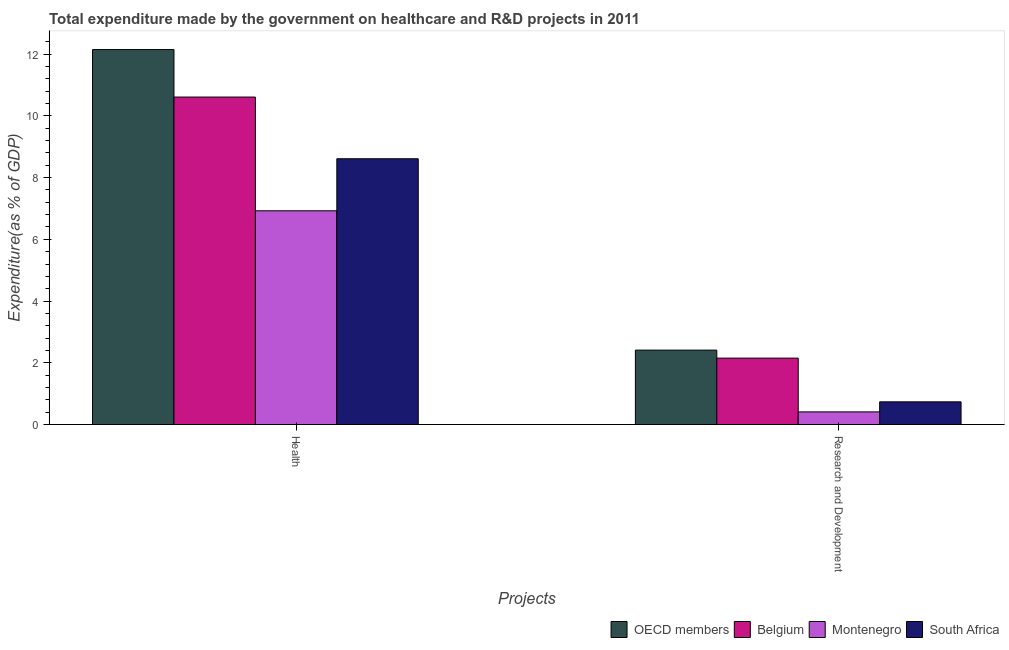How many groups of bars are there?
Make the answer very short. 2. Are the number of bars on each tick of the X-axis equal?
Provide a succinct answer. Yes. How many bars are there on the 1st tick from the left?
Provide a succinct answer. 4. How many bars are there on the 1st tick from the right?
Make the answer very short. 4. What is the label of the 2nd group of bars from the left?
Offer a very short reply. Research and Development. What is the expenditure in healthcare in OECD members?
Provide a short and direct response. 12.15. Across all countries, what is the maximum expenditure in healthcare?
Your answer should be compact. 12.15. Across all countries, what is the minimum expenditure in healthcare?
Keep it short and to the point. 6.92. In which country was the expenditure in healthcare minimum?
Ensure brevity in your answer.  Montenegro. What is the total expenditure in healthcare in the graph?
Your response must be concise. 38.3. What is the difference between the expenditure in healthcare in Montenegro and that in OECD members?
Provide a short and direct response. -5.22. What is the difference between the expenditure in healthcare in OECD members and the expenditure in r&d in South Africa?
Keep it short and to the point. 11.41. What is the average expenditure in r&d per country?
Keep it short and to the point. 1.43. What is the difference between the expenditure in healthcare and expenditure in r&d in South Africa?
Offer a terse response. 7.88. In how many countries, is the expenditure in healthcare greater than 2.8 %?
Make the answer very short. 4. What is the ratio of the expenditure in r&d in OECD members to that in Belgium?
Your answer should be very brief. 1.12. What does the 1st bar from the left in Health represents?
Provide a short and direct response. OECD members. What does the 2nd bar from the right in Health represents?
Your response must be concise. Montenegro. Are all the bars in the graph horizontal?
Keep it short and to the point. No. How many countries are there in the graph?
Provide a short and direct response. 4. What is the difference between two consecutive major ticks on the Y-axis?
Provide a short and direct response. 2. What is the title of the graph?
Keep it short and to the point. Total expenditure made by the government on healthcare and R&D projects in 2011. What is the label or title of the X-axis?
Provide a succinct answer. Projects. What is the label or title of the Y-axis?
Ensure brevity in your answer.  Expenditure(as % of GDP). What is the Expenditure(as % of GDP) of OECD members in Health?
Your answer should be very brief. 12.15. What is the Expenditure(as % of GDP) in Belgium in Health?
Your answer should be compact. 10.61. What is the Expenditure(as % of GDP) of Montenegro in Health?
Your response must be concise. 6.92. What is the Expenditure(as % of GDP) of South Africa in Health?
Your response must be concise. 8.61. What is the Expenditure(as % of GDP) in OECD members in Research and Development?
Your answer should be very brief. 2.41. What is the Expenditure(as % of GDP) of Belgium in Research and Development?
Ensure brevity in your answer.  2.15. What is the Expenditure(as % of GDP) of Montenegro in Research and Development?
Offer a terse response. 0.41. What is the Expenditure(as % of GDP) in South Africa in Research and Development?
Ensure brevity in your answer.  0.73. Across all Projects, what is the maximum Expenditure(as % of GDP) in OECD members?
Offer a very short reply. 12.15. Across all Projects, what is the maximum Expenditure(as % of GDP) in Belgium?
Make the answer very short. 10.61. Across all Projects, what is the maximum Expenditure(as % of GDP) in Montenegro?
Ensure brevity in your answer.  6.92. Across all Projects, what is the maximum Expenditure(as % of GDP) of South Africa?
Your response must be concise. 8.61. Across all Projects, what is the minimum Expenditure(as % of GDP) of OECD members?
Provide a short and direct response. 2.41. Across all Projects, what is the minimum Expenditure(as % of GDP) in Belgium?
Your response must be concise. 2.15. Across all Projects, what is the minimum Expenditure(as % of GDP) in Montenegro?
Make the answer very short. 0.41. Across all Projects, what is the minimum Expenditure(as % of GDP) in South Africa?
Provide a succinct answer. 0.73. What is the total Expenditure(as % of GDP) in OECD members in the graph?
Ensure brevity in your answer.  14.56. What is the total Expenditure(as % of GDP) in Belgium in the graph?
Keep it short and to the point. 12.76. What is the total Expenditure(as % of GDP) in Montenegro in the graph?
Ensure brevity in your answer.  7.33. What is the total Expenditure(as % of GDP) of South Africa in the graph?
Offer a very short reply. 9.35. What is the difference between the Expenditure(as % of GDP) of OECD members in Health and that in Research and Development?
Offer a very short reply. 9.74. What is the difference between the Expenditure(as % of GDP) of Belgium in Health and that in Research and Development?
Offer a very short reply. 8.46. What is the difference between the Expenditure(as % of GDP) in Montenegro in Health and that in Research and Development?
Your answer should be compact. 6.52. What is the difference between the Expenditure(as % of GDP) in South Africa in Health and that in Research and Development?
Make the answer very short. 7.88. What is the difference between the Expenditure(as % of GDP) of OECD members in Health and the Expenditure(as % of GDP) of Belgium in Research and Development?
Ensure brevity in your answer.  10. What is the difference between the Expenditure(as % of GDP) of OECD members in Health and the Expenditure(as % of GDP) of Montenegro in Research and Development?
Offer a terse response. 11.74. What is the difference between the Expenditure(as % of GDP) in OECD members in Health and the Expenditure(as % of GDP) in South Africa in Research and Development?
Your answer should be very brief. 11.41. What is the difference between the Expenditure(as % of GDP) in Belgium in Health and the Expenditure(as % of GDP) in Montenegro in Research and Development?
Your response must be concise. 10.2. What is the difference between the Expenditure(as % of GDP) of Belgium in Health and the Expenditure(as % of GDP) of South Africa in Research and Development?
Give a very brief answer. 9.88. What is the difference between the Expenditure(as % of GDP) in Montenegro in Health and the Expenditure(as % of GDP) in South Africa in Research and Development?
Make the answer very short. 6.19. What is the average Expenditure(as % of GDP) in OECD members per Projects?
Offer a terse response. 7.28. What is the average Expenditure(as % of GDP) of Belgium per Projects?
Keep it short and to the point. 6.38. What is the average Expenditure(as % of GDP) of Montenegro per Projects?
Make the answer very short. 3.67. What is the average Expenditure(as % of GDP) in South Africa per Projects?
Provide a succinct answer. 4.67. What is the difference between the Expenditure(as % of GDP) of OECD members and Expenditure(as % of GDP) of Belgium in Health?
Provide a short and direct response. 1.54. What is the difference between the Expenditure(as % of GDP) of OECD members and Expenditure(as % of GDP) of Montenegro in Health?
Ensure brevity in your answer.  5.22. What is the difference between the Expenditure(as % of GDP) in OECD members and Expenditure(as % of GDP) in South Africa in Health?
Provide a short and direct response. 3.54. What is the difference between the Expenditure(as % of GDP) of Belgium and Expenditure(as % of GDP) of Montenegro in Health?
Your answer should be very brief. 3.69. What is the difference between the Expenditure(as % of GDP) of Belgium and Expenditure(as % of GDP) of South Africa in Health?
Keep it short and to the point. 2. What is the difference between the Expenditure(as % of GDP) of Montenegro and Expenditure(as % of GDP) of South Africa in Health?
Your response must be concise. -1.69. What is the difference between the Expenditure(as % of GDP) of OECD members and Expenditure(as % of GDP) of Belgium in Research and Development?
Your response must be concise. 0.26. What is the difference between the Expenditure(as % of GDP) in OECD members and Expenditure(as % of GDP) in Montenegro in Research and Development?
Provide a succinct answer. 2. What is the difference between the Expenditure(as % of GDP) of OECD members and Expenditure(as % of GDP) of South Africa in Research and Development?
Provide a succinct answer. 1.68. What is the difference between the Expenditure(as % of GDP) of Belgium and Expenditure(as % of GDP) of Montenegro in Research and Development?
Offer a very short reply. 1.74. What is the difference between the Expenditure(as % of GDP) of Belgium and Expenditure(as % of GDP) of South Africa in Research and Development?
Ensure brevity in your answer.  1.42. What is the difference between the Expenditure(as % of GDP) of Montenegro and Expenditure(as % of GDP) of South Africa in Research and Development?
Give a very brief answer. -0.33. What is the ratio of the Expenditure(as % of GDP) in OECD members in Health to that in Research and Development?
Ensure brevity in your answer.  5.04. What is the ratio of the Expenditure(as % of GDP) of Belgium in Health to that in Research and Development?
Keep it short and to the point. 4.93. What is the ratio of the Expenditure(as % of GDP) in Montenegro in Health to that in Research and Development?
Provide a short and direct response. 16.95. What is the ratio of the Expenditure(as % of GDP) in South Africa in Health to that in Research and Development?
Provide a short and direct response. 11.73. What is the difference between the highest and the second highest Expenditure(as % of GDP) of OECD members?
Your response must be concise. 9.74. What is the difference between the highest and the second highest Expenditure(as % of GDP) in Belgium?
Provide a short and direct response. 8.46. What is the difference between the highest and the second highest Expenditure(as % of GDP) of Montenegro?
Offer a very short reply. 6.52. What is the difference between the highest and the second highest Expenditure(as % of GDP) in South Africa?
Your answer should be very brief. 7.88. What is the difference between the highest and the lowest Expenditure(as % of GDP) in OECD members?
Your answer should be compact. 9.74. What is the difference between the highest and the lowest Expenditure(as % of GDP) in Belgium?
Give a very brief answer. 8.46. What is the difference between the highest and the lowest Expenditure(as % of GDP) in Montenegro?
Provide a short and direct response. 6.52. What is the difference between the highest and the lowest Expenditure(as % of GDP) in South Africa?
Keep it short and to the point. 7.88. 